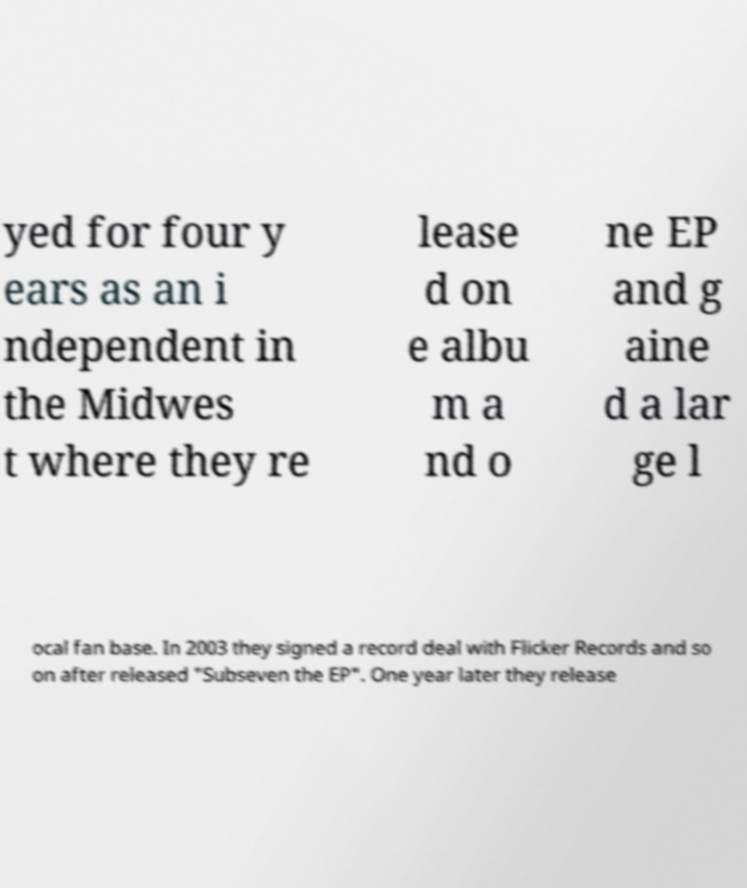For documentation purposes, I need the text within this image transcribed. Could you provide that? yed for four y ears as an i ndependent in the Midwes t where they re lease d on e albu m a nd o ne EP and g aine d a lar ge l ocal fan base. In 2003 they signed a record deal with Flicker Records and so on after released "Subseven the EP". One year later they release 